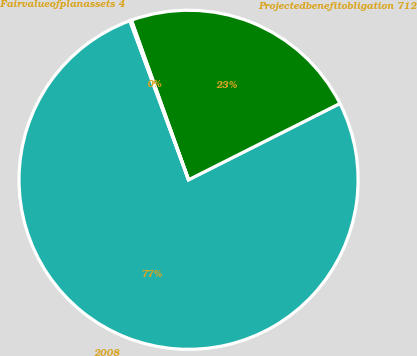<chart> <loc_0><loc_0><loc_500><loc_500><pie_chart><fcel>2008<fcel>Projectedbenefitobligation 712<fcel>Fairvalueofplanassets 4<nl><fcel>76.81%<fcel>23.04%<fcel>0.15%<nl></chart> 